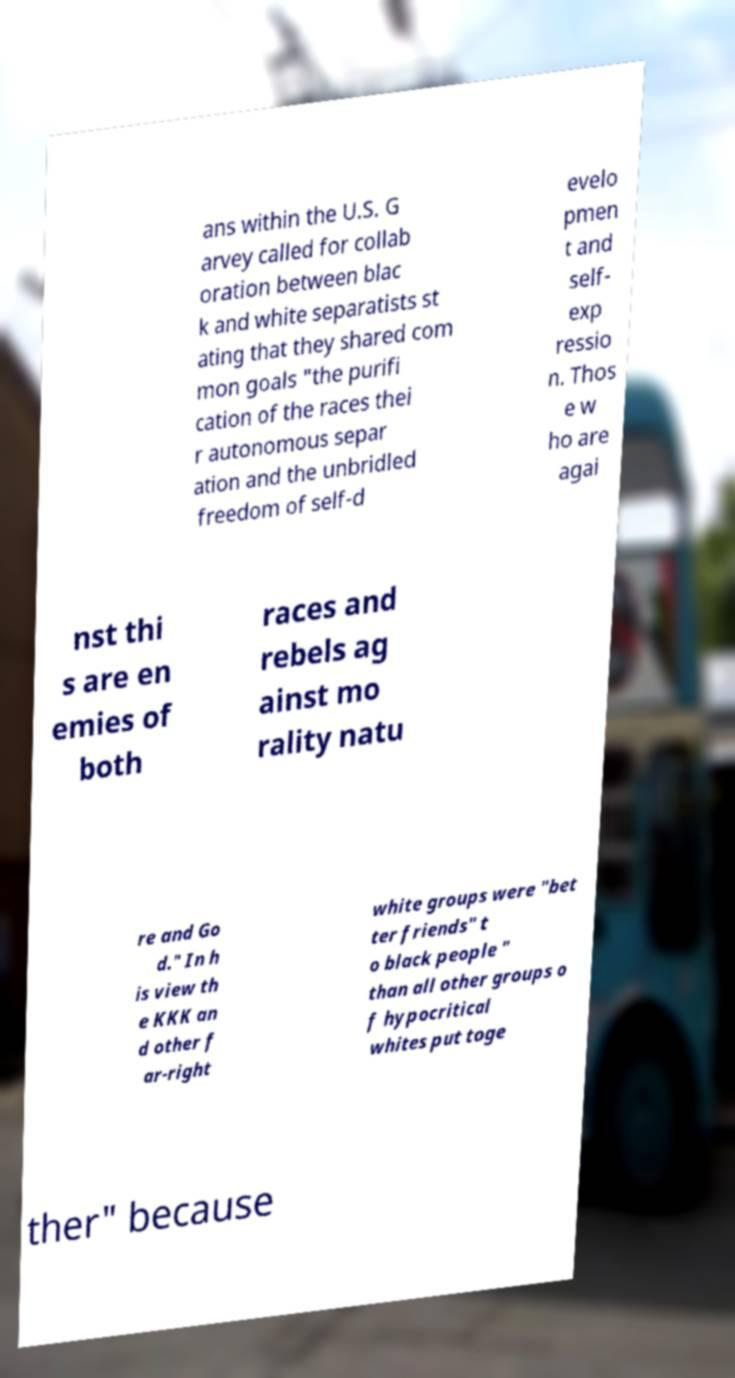Could you assist in decoding the text presented in this image and type it out clearly? ans within the U.S. G arvey called for collab oration between blac k and white separatists st ating that they shared com mon goals "the purifi cation of the races thei r autonomous separ ation and the unbridled freedom of self-d evelo pmen t and self- exp ressio n. Thos e w ho are agai nst thi s are en emies of both races and rebels ag ainst mo rality natu re and Go d." In h is view th e KKK an d other f ar-right white groups were "bet ter friends" t o black people " than all other groups o f hypocritical whites put toge ther" because 